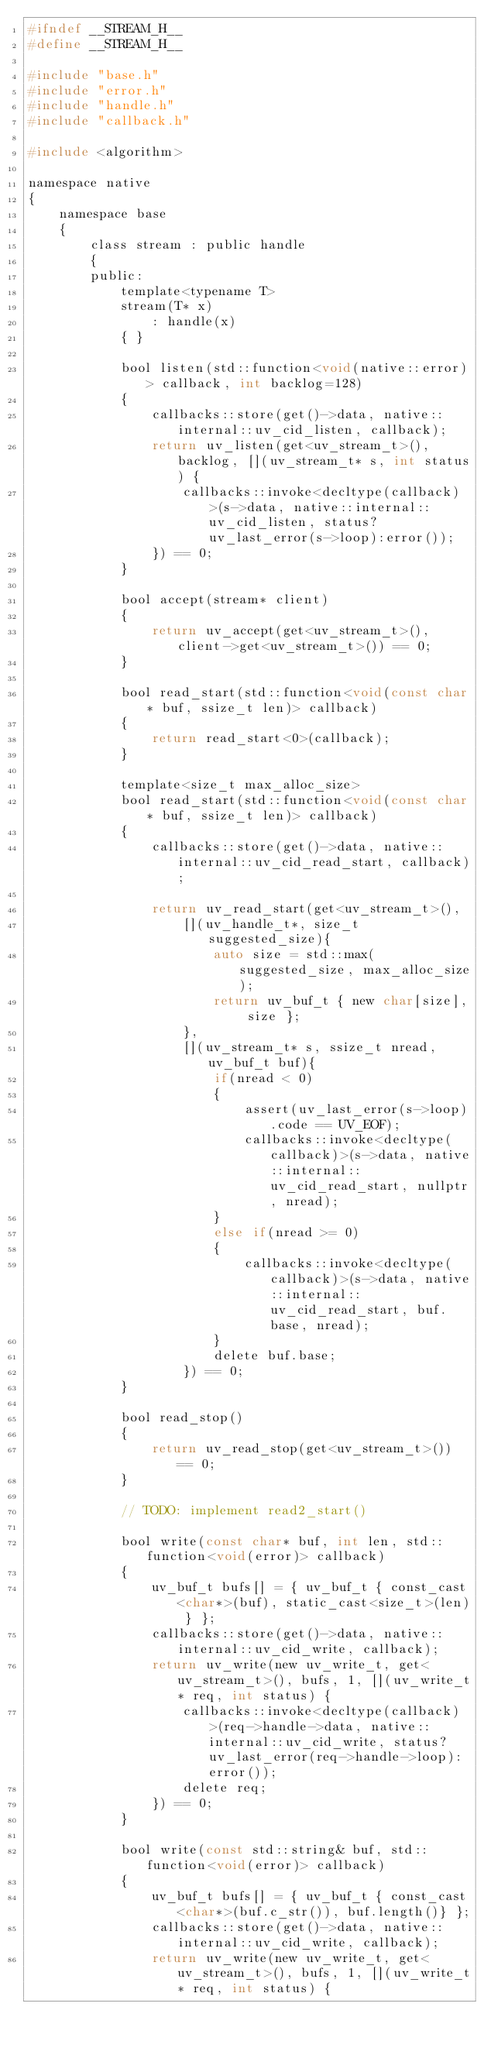<code> <loc_0><loc_0><loc_500><loc_500><_C_>#ifndef __STREAM_H__
#define __STREAM_H__

#include "base.h"
#include "error.h"
#include "handle.h"
#include "callback.h"

#include <algorithm>

namespace native
{
    namespace base
    {
        class stream : public handle
        {
        public:
            template<typename T>
            stream(T* x)
                : handle(x)
            { }

            bool listen(std::function<void(native::error)> callback, int backlog=128)
            {
                callbacks::store(get()->data, native::internal::uv_cid_listen, callback);
                return uv_listen(get<uv_stream_t>(), backlog, [](uv_stream_t* s, int status) {
                    callbacks::invoke<decltype(callback)>(s->data, native::internal::uv_cid_listen, status?uv_last_error(s->loop):error());
                }) == 0;
            }

            bool accept(stream* client)
            {
                return uv_accept(get<uv_stream_t>(), client->get<uv_stream_t>()) == 0;
            }

            bool read_start(std::function<void(const char* buf, ssize_t len)> callback)
            {
                return read_start<0>(callback);
            }

            template<size_t max_alloc_size>
            bool read_start(std::function<void(const char* buf, ssize_t len)> callback)
            {
                callbacks::store(get()->data, native::internal::uv_cid_read_start, callback);

                return uv_read_start(get<uv_stream_t>(),
                    [](uv_handle_t*, size_t suggested_size){
                        auto size = std::max(suggested_size, max_alloc_size);
                        return uv_buf_t { new char[size], size };
                    },
                    [](uv_stream_t* s, ssize_t nread, uv_buf_t buf){
                        if(nread < 0)
                        {
                            assert(uv_last_error(s->loop).code == UV_EOF);
                            callbacks::invoke<decltype(callback)>(s->data, native::internal::uv_cid_read_start, nullptr, nread);
                        }
                        else if(nread >= 0)
                        {
                            callbacks::invoke<decltype(callback)>(s->data, native::internal::uv_cid_read_start, buf.base, nread);
                        }
                        delete buf.base;
                    }) == 0;
            }

            bool read_stop()
            {
                return uv_read_stop(get<uv_stream_t>()) == 0;
            }

            // TODO: implement read2_start()

            bool write(const char* buf, int len, std::function<void(error)> callback)
            {
                uv_buf_t bufs[] = { uv_buf_t { const_cast<char*>(buf), static_cast<size_t>(len) } };
                callbacks::store(get()->data, native::internal::uv_cid_write, callback);
                return uv_write(new uv_write_t, get<uv_stream_t>(), bufs, 1, [](uv_write_t* req, int status) {
                    callbacks::invoke<decltype(callback)>(req->handle->data, native::internal::uv_cid_write, status?uv_last_error(req->handle->loop):error());
                    delete req;
                }) == 0;
            }

            bool write(const std::string& buf, std::function<void(error)> callback)
            {
                uv_buf_t bufs[] = { uv_buf_t { const_cast<char*>(buf.c_str()), buf.length()} };
                callbacks::store(get()->data, native::internal::uv_cid_write, callback);
                return uv_write(new uv_write_t, get<uv_stream_t>(), bufs, 1, [](uv_write_t* req, int status) {</code> 